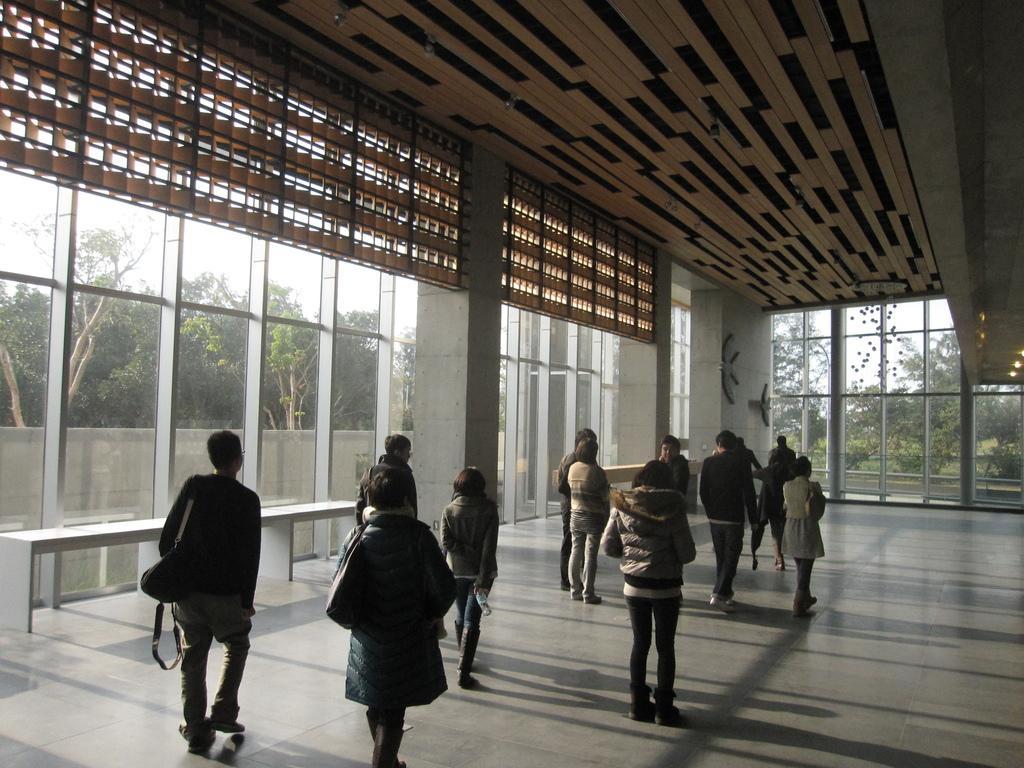How would you summarize this image in a sentence or two? In this picture we can see there is a group of people standing on the floor. Behind the people, there are glass windows. Behind the windows, there is a wall, trees and the sky. 